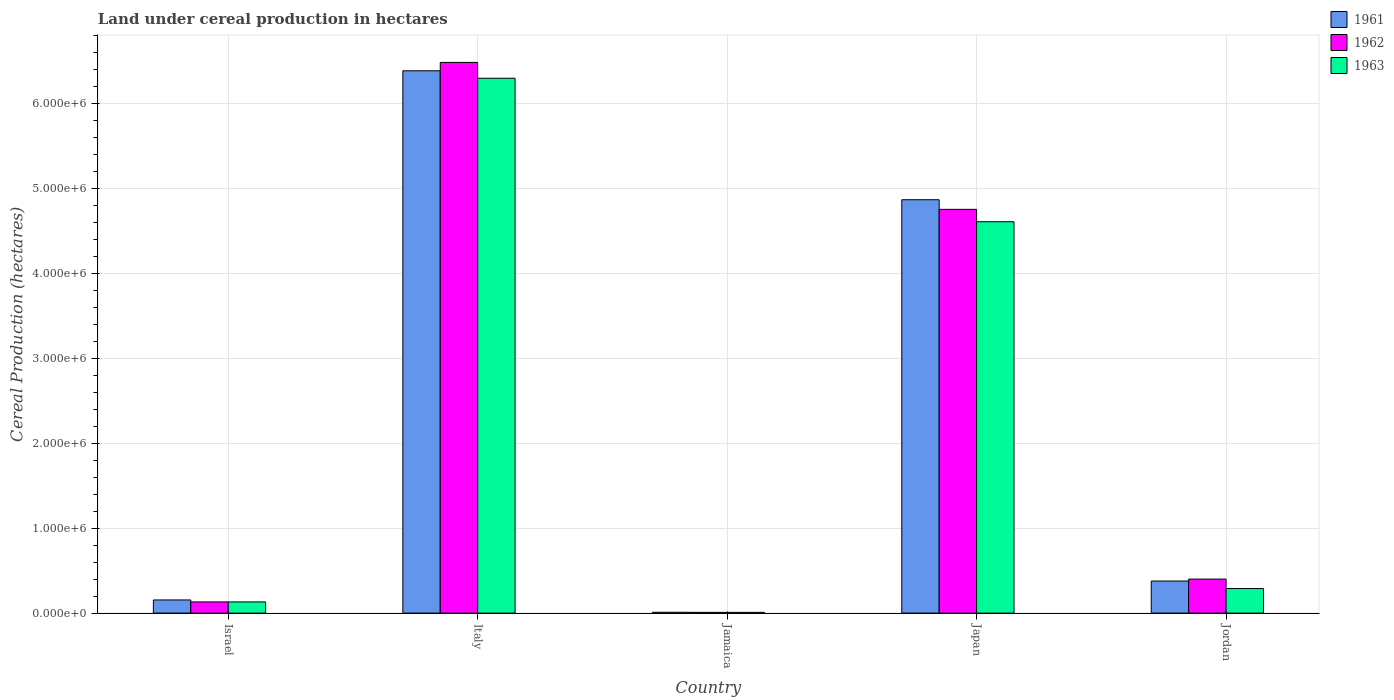How many groups of bars are there?
Your response must be concise. 5. Are the number of bars on each tick of the X-axis equal?
Offer a terse response. Yes. How many bars are there on the 4th tick from the right?
Your response must be concise. 3. What is the label of the 5th group of bars from the left?
Make the answer very short. Jordan. What is the land under cereal production in 1962 in Japan?
Make the answer very short. 4.76e+06. Across all countries, what is the maximum land under cereal production in 1961?
Make the answer very short. 6.39e+06. Across all countries, what is the minimum land under cereal production in 1962?
Your answer should be very brief. 8579. In which country was the land under cereal production in 1963 minimum?
Make the answer very short. Jamaica. What is the total land under cereal production in 1962 in the graph?
Make the answer very short. 1.18e+07. What is the difference between the land under cereal production in 1963 in Jamaica and that in Jordan?
Ensure brevity in your answer.  -2.80e+05. What is the difference between the land under cereal production in 1962 in Israel and the land under cereal production in 1961 in Jamaica?
Give a very brief answer. 1.22e+05. What is the average land under cereal production in 1961 per country?
Give a very brief answer. 2.36e+06. What is the difference between the land under cereal production of/in 1963 and land under cereal production of/in 1962 in Italy?
Offer a very short reply. -1.86e+05. What is the ratio of the land under cereal production in 1961 in Japan to that in Jordan?
Your answer should be very brief. 12.89. Is the land under cereal production in 1961 in Israel less than that in Italy?
Ensure brevity in your answer.  Yes. Is the difference between the land under cereal production in 1963 in Italy and Jordan greater than the difference between the land under cereal production in 1962 in Italy and Jordan?
Your response must be concise. No. What is the difference between the highest and the second highest land under cereal production in 1961?
Offer a very short reply. -1.52e+06. What is the difference between the highest and the lowest land under cereal production in 1963?
Your answer should be compact. 6.29e+06. What does the 1st bar from the left in Italy represents?
Keep it short and to the point. 1961. Is it the case that in every country, the sum of the land under cereal production in 1961 and land under cereal production in 1963 is greater than the land under cereal production in 1962?
Your answer should be very brief. Yes. What is the difference between two consecutive major ticks on the Y-axis?
Provide a short and direct response. 1.00e+06. Does the graph contain any zero values?
Keep it short and to the point. No. Does the graph contain grids?
Give a very brief answer. Yes. Where does the legend appear in the graph?
Make the answer very short. Top right. How many legend labels are there?
Your answer should be compact. 3. What is the title of the graph?
Give a very brief answer. Land under cereal production in hectares. Does "2011" appear as one of the legend labels in the graph?
Ensure brevity in your answer.  No. What is the label or title of the X-axis?
Your answer should be compact. Country. What is the label or title of the Y-axis?
Give a very brief answer. Cereal Production (hectares). What is the Cereal Production (hectares) in 1961 in Israel?
Your response must be concise. 1.55e+05. What is the Cereal Production (hectares) in 1962 in Israel?
Offer a very short reply. 1.32e+05. What is the Cereal Production (hectares) in 1963 in Israel?
Provide a short and direct response. 1.32e+05. What is the Cereal Production (hectares) in 1961 in Italy?
Give a very brief answer. 6.39e+06. What is the Cereal Production (hectares) in 1962 in Italy?
Keep it short and to the point. 6.49e+06. What is the Cereal Production (hectares) of 1963 in Italy?
Offer a terse response. 6.30e+06. What is the Cereal Production (hectares) of 1961 in Jamaica?
Make the answer very short. 9712. What is the Cereal Production (hectares) of 1962 in Jamaica?
Your answer should be very brief. 8579. What is the Cereal Production (hectares) in 1963 in Jamaica?
Your response must be concise. 8619. What is the Cereal Production (hectares) in 1961 in Japan?
Offer a terse response. 4.87e+06. What is the Cereal Production (hectares) of 1962 in Japan?
Give a very brief answer. 4.76e+06. What is the Cereal Production (hectares) of 1963 in Japan?
Give a very brief answer. 4.61e+06. What is the Cereal Production (hectares) of 1961 in Jordan?
Provide a short and direct response. 3.78e+05. What is the Cereal Production (hectares) of 1962 in Jordan?
Offer a terse response. 4.01e+05. What is the Cereal Production (hectares) of 1963 in Jordan?
Your answer should be compact. 2.89e+05. Across all countries, what is the maximum Cereal Production (hectares) of 1961?
Your response must be concise. 6.39e+06. Across all countries, what is the maximum Cereal Production (hectares) in 1962?
Provide a succinct answer. 6.49e+06. Across all countries, what is the maximum Cereal Production (hectares) of 1963?
Offer a terse response. 6.30e+06. Across all countries, what is the minimum Cereal Production (hectares) in 1961?
Your response must be concise. 9712. Across all countries, what is the minimum Cereal Production (hectares) in 1962?
Your answer should be compact. 8579. Across all countries, what is the minimum Cereal Production (hectares) of 1963?
Give a very brief answer. 8619. What is the total Cereal Production (hectares) of 1961 in the graph?
Make the answer very short. 1.18e+07. What is the total Cereal Production (hectares) of 1962 in the graph?
Offer a very short reply. 1.18e+07. What is the total Cereal Production (hectares) in 1963 in the graph?
Your answer should be very brief. 1.13e+07. What is the difference between the Cereal Production (hectares) of 1961 in Israel and that in Italy?
Ensure brevity in your answer.  -6.23e+06. What is the difference between the Cereal Production (hectares) in 1962 in Israel and that in Italy?
Provide a short and direct response. -6.35e+06. What is the difference between the Cereal Production (hectares) of 1963 in Israel and that in Italy?
Give a very brief answer. -6.17e+06. What is the difference between the Cereal Production (hectares) of 1961 in Israel and that in Jamaica?
Your answer should be very brief. 1.45e+05. What is the difference between the Cereal Production (hectares) in 1962 in Israel and that in Jamaica?
Provide a short and direct response. 1.23e+05. What is the difference between the Cereal Production (hectares) of 1963 in Israel and that in Jamaica?
Offer a very short reply. 1.23e+05. What is the difference between the Cereal Production (hectares) of 1961 in Israel and that in Japan?
Keep it short and to the point. -4.71e+06. What is the difference between the Cereal Production (hectares) of 1962 in Israel and that in Japan?
Ensure brevity in your answer.  -4.62e+06. What is the difference between the Cereal Production (hectares) in 1963 in Israel and that in Japan?
Provide a succinct answer. -4.48e+06. What is the difference between the Cereal Production (hectares) of 1961 in Israel and that in Jordan?
Ensure brevity in your answer.  -2.23e+05. What is the difference between the Cereal Production (hectares) in 1962 in Israel and that in Jordan?
Your answer should be very brief. -2.69e+05. What is the difference between the Cereal Production (hectares) in 1963 in Israel and that in Jordan?
Provide a succinct answer. -1.57e+05. What is the difference between the Cereal Production (hectares) of 1961 in Italy and that in Jamaica?
Offer a very short reply. 6.38e+06. What is the difference between the Cereal Production (hectares) of 1962 in Italy and that in Jamaica?
Your response must be concise. 6.48e+06. What is the difference between the Cereal Production (hectares) in 1963 in Italy and that in Jamaica?
Provide a short and direct response. 6.29e+06. What is the difference between the Cereal Production (hectares) in 1961 in Italy and that in Japan?
Your answer should be compact. 1.52e+06. What is the difference between the Cereal Production (hectares) in 1962 in Italy and that in Japan?
Your answer should be very brief. 1.73e+06. What is the difference between the Cereal Production (hectares) of 1963 in Italy and that in Japan?
Provide a short and direct response. 1.69e+06. What is the difference between the Cereal Production (hectares) of 1961 in Italy and that in Jordan?
Keep it short and to the point. 6.01e+06. What is the difference between the Cereal Production (hectares) of 1962 in Italy and that in Jordan?
Your answer should be compact. 6.09e+06. What is the difference between the Cereal Production (hectares) in 1963 in Italy and that in Jordan?
Give a very brief answer. 6.01e+06. What is the difference between the Cereal Production (hectares) in 1961 in Jamaica and that in Japan?
Provide a short and direct response. -4.86e+06. What is the difference between the Cereal Production (hectares) of 1962 in Jamaica and that in Japan?
Give a very brief answer. -4.75e+06. What is the difference between the Cereal Production (hectares) in 1963 in Jamaica and that in Japan?
Your answer should be compact. -4.60e+06. What is the difference between the Cereal Production (hectares) in 1961 in Jamaica and that in Jordan?
Offer a very short reply. -3.68e+05. What is the difference between the Cereal Production (hectares) of 1962 in Jamaica and that in Jordan?
Your response must be concise. -3.92e+05. What is the difference between the Cereal Production (hectares) in 1963 in Jamaica and that in Jordan?
Offer a very short reply. -2.80e+05. What is the difference between the Cereal Production (hectares) in 1961 in Japan and that in Jordan?
Make the answer very short. 4.49e+06. What is the difference between the Cereal Production (hectares) in 1962 in Japan and that in Jordan?
Offer a terse response. 4.35e+06. What is the difference between the Cereal Production (hectares) in 1963 in Japan and that in Jordan?
Your response must be concise. 4.32e+06. What is the difference between the Cereal Production (hectares) in 1961 in Israel and the Cereal Production (hectares) in 1962 in Italy?
Your response must be concise. -6.33e+06. What is the difference between the Cereal Production (hectares) in 1961 in Israel and the Cereal Production (hectares) in 1963 in Italy?
Your answer should be very brief. -6.14e+06. What is the difference between the Cereal Production (hectares) in 1962 in Israel and the Cereal Production (hectares) in 1963 in Italy?
Offer a very short reply. -6.17e+06. What is the difference between the Cereal Production (hectares) of 1961 in Israel and the Cereal Production (hectares) of 1962 in Jamaica?
Make the answer very short. 1.46e+05. What is the difference between the Cereal Production (hectares) in 1961 in Israel and the Cereal Production (hectares) in 1963 in Jamaica?
Give a very brief answer. 1.46e+05. What is the difference between the Cereal Production (hectares) in 1962 in Israel and the Cereal Production (hectares) in 1963 in Jamaica?
Offer a terse response. 1.23e+05. What is the difference between the Cereal Production (hectares) of 1961 in Israel and the Cereal Production (hectares) of 1962 in Japan?
Your response must be concise. -4.60e+06. What is the difference between the Cereal Production (hectares) in 1961 in Israel and the Cereal Production (hectares) in 1963 in Japan?
Your response must be concise. -4.45e+06. What is the difference between the Cereal Production (hectares) in 1962 in Israel and the Cereal Production (hectares) in 1963 in Japan?
Your answer should be compact. -4.48e+06. What is the difference between the Cereal Production (hectares) of 1961 in Israel and the Cereal Production (hectares) of 1962 in Jordan?
Provide a succinct answer. -2.46e+05. What is the difference between the Cereal Production (hectares) of 1961 in Israel and the Cereal Production (hectares) of 1963 in Jordan?
Provide a succinct answer. -1.34e+05. What is the difference between the Cereal Production (hectares) of 1962 in Israel and the Cereal Production (hectares) of 1963 in Jordan?
Ensure brevity in your answer.  -1.57e+05. What is the difference between the Cereal Production (hectares) in 1961 in Italy and the Cereal Production (hectares) in 1962 in Jamaica?
Make the answer very short. 6.38e+06. What is the difference between the Cereal Production (hectares) in 1961 in Italy and the Cereal Production (hectares) in 1963 in Jamaica?
Ensure brevity in your answer.  6.38e+06. What is the difference between the Cereal Production (hectares) in 1962 in Italy and the Cereal Production (hectares) in 1963 in Jamaica?
Your response must be concise. 6.48e+06. What is the difference between the Cereal Production (hectares) in 1961 in Italy and the Cereal Production (hectares) in 1962 in Japan?
Offer a terse response. 1.63e+06. What is the difference between the Cereal Production (hectares) of 1961 in Italy and the Cereal Production (hectares) of 1963 in Japan?
Offer a very short reply. 1.78e+06. What is the difference between the Cereal Production (hectares) of 1962 in Italy and the Cereal Production (hectares) of 1963 in Japan?
Your answer should be very brief. 1.88e+06. What is the difference between the Cereal Production (hectares) of 1961 in Italy and the Cereal Production (hectares) of 1962 in Jordan?
Your answer should be compact. 5.99e+06. What is the difference between the Cereal Production (hectares) in 1961 in Italy and the Cereal Production (hectares) in 1963 in Jordan?
Provide a succinct answer. 6.10e+06. What is the difference between the Cereal Production (hectares) of 1962 in Italy and the Cereal Production (hectares) of 1963 in Jordan?
Keep it short and to the point. 6.20e+06. What is the difference between the Cereal Production (hectares) in 1961 in Jamaica and the Cereal Production (hectares) in 1962 in Japan?
Provide a succinct answer. -4.75e+06. What is the difference between the Cereal Production (hectares) in 1961 in Jamaica and the Cereal Production (hectares) in 1963 in Japan?
Your answer should be very brief. -4.60e+06. What is the difference between the Cereal Production (hectares) in 1962 in Jamaica and the Cereal Production (hectares) in 1963 in Japan?
Give a very brief answer. -4.60e+06. What is the difference between the Cereal Production (hectares) in 1961 in Jamaica and the Cereal Production (hectares) in 1962 in Jordan?
Offer a very short reply. -3.91e+05. What is the difference between the Cereal Production (hectares) in 1961 in Jamaica and the Cereal Production (hectares) in 1963 in Jordan?
Your answer should be very brief. -2.79e+05. What is the difference between the Cereal Production (hectares) of 1962 in Jamaica and the Cereal Production (hectares) of 1963 in Jordan?
Make the answer very short. -2.80e+05. What is the difference between the Cereal Production (hectares) in 1961 in Japan and the Cereal Production (hectares) in 1962 in Jordan?
Provide a short and direct response. 4.47e+06. What is the difference between the Cereal Production (hectares) in 1961 in Japan and the Cereal Production (hectares) in 1963 in Jordan?
Ensure brevity in your answer.  4.58e+06. What is the difference between the Cereal Production (hectares) of 1962 in Japan and the Cereal Production (hectares) of 1963 in Jordan?
Keep it short and to the point. 4.47e+06. What is the average Cereal Production (hectares) of 1961 per country?
Keep it short and to the point. 2.36e+06. What is the average Cereal Production (hectares) in 1962 per country?
Keep it short and to the point. 2.36e+06. What is the average Cereal Production (hectares) in 1963 per country?
Offer a terse response. 2.27e+06. What is the difference between the Cereal Production (hectares) in 1961 and Cereal Production (hectares) in 1962 in Israel?
Provide a succinct answer. 2.32e+04. What is the difference between the Cereal Production (hectares) of 1961 and Cereal Production (hectares) of 1963 in Israel?
Your answer should be compact. 2.31e+04. What is the difference between the Cereal Production (hectares) of 1962 and Cereal Production (hectares) of 1963 in Israel?
Offer a very short reply. -132. What is the difference between the Cereal Production (hectares) of 1961 and Cereal Production (hectares) of 1962 in Italy?
Make the answer very short. -9.87e+04. What is the difference between the Cereal Production (hectares) of 1961 and Cereal Production (hectares) of 1963 in Italy?
Make the answer very short. 8.77e+04. What is the difference between the Cereal Production (hectares) of 1962 and Cereal Production (hectares) of 1963 in Italy?
Offer a terse response. 1.86e+05. What is the difference between the Cereal Production (hectares) of 1961 and Cereal Production (hectares) of 1962 in Jamaica?
Provide a short and direct response. 1133. What is the difference between the Cereal Production (hectares) of 1961 and Cereal Production (hectares) of 1963 in Jamaica?
Offer a very short reply. 1093. What is the difference between the Cereal Production (hectares) of 1961 and Cereal Production (hectares) of 1962 in Japan?
Make the answer very short. 1.13e+05. What is the difference between the Cereal Production (hectares) of 1961 and Cereal Production (hectares) of 1963 in Japan?
Your answer should be compact. 2.59e+05. What is the difference between the Cereal Production (hectares) of 1962 and Cereal Production (hectares) of 1963 in Japan?
Offer a very short reply. 1.46e+05. What is the difference between the Cereal Production (hectares) in 1961 and Cereal Production (hectares) in 1962 in Jordan?
Keep it short and to the point. -2.28e+04. What is the difference between the Cereal Production (hectares) of 1961 and Cereal Production (hectares) of 1963 in Jordan?
Ensure brevity in your answer.  8.87e+04. What is the difference between the Cereal Production (hectares) in 1962 and Cereal Production (hectares) in 1963 in Jordan?
Offer a terse response. 1.12e+05. What is the ratio of the Cereal Production (hectares) of 1961 in Israel to that in Italy?
Offer a terse response. 0.02. What is the ratio of the Cereal Production (hectares) in 1962 in Israel to that in Italy?
Give a very brief answer. 0.02. What is the ratio of the Cereal Production (hectares) in 1963 in Israel to that in Italy?
Provide a short and direct response. 0.02. What is the ratio of the Cereal Production (hectares) in 1961 in Israel to that in Jamaica?
Offer a very short reply. 15.95. What is the ratio of the Cereal Production (hectares) in 1962 in Israel to that in Jamaica?
Your response must be concise. 15.34. What is the ratio of the Cereal Production (hectares) of 1963 in Israel to that in Jamaica?
Offer a terse response. 15.29. What is the ratio of the Cereal Production (hectares) in 1961 in Israel to that in Japan?
Your answer should be very brief. 0.03. What is the ratio of the Cereal Production (hectares) of 1962 in Israel to that in Japan?
Keep it short and to the point. 0.03. What is the ratio of the Cereal Production (hectares) of 1963 in Israel to that in Japan?
Your answer should be compact. 0.03. What is the ratio of the Cereal Production (hectares) of 1961 in Israel to that in Jordan?
Your response must be concise. 0.41. What is the ratio of the Cereal Production (hectares) of 1962 in Israel to that in Jordan?
Provide a short and direct response. 0.33. What is the ratio of the Cereal Production (hectares) of 1963 in Israel to that in Jordan?
Give a very brief answer. 0.46. What is the ratio of the Cereal Production (hectares) in 1961 in Italy to that in Jamaica?
Give a very brief answer. 657.66. What is the ratio of the Cereal Production (hectares) of 1962 in Italy to that in Jamaica?
Provide a short and direct response. 756.02. What is the ratio of the Cereal Production (hectares) in 1963 in Italy to that in Jamaica?
Your answer should be compact. 730.88. What is the ratio of the Cereal Production (hectares) in 1961 in Italy to that in Japan?
Your answer should be compact. 1.31. What is the ratio of the Cereal Production (hectares) in 1962 in Italy to that in Japan?
Provide a succinct answer. 1.36. What is the ratio of the Cereal Production (hectares) in 1963 in Italy to that in Japan?
Make the answer very short. 1.37. What is the ratio of the Cereal Production (hectares) in 1961 in Italy to that in Jordan?
Offer a terse response. 16.91. What is the ratio of the Cereal Production (hectares) of 1962 in Italy to that in Jordan?
Give a very brief answer. 16.19. What is the ratio of the Cereal Production (hectares) in 1963 in Italy to that in Jordan?
Provide a succinct answer. 21.79. What is the ratio of the Cereal Production (hectares) in 1961 in Jamaica to that in Japan?
Your answer should be compact. 0. What is the ratio of the Cereal Production (hectares) of 1962 in Jamaica to that in Japan?
Give a very brief answer. 0. What is the ratio of the Cereal Production (hectares) in 1963 in Jamaica to that in Japan?
Your answer should be compact. 0. What is the ratio of the Cereal Production (hectares) of 1961 in Jamaica to that in Jordan?
Make the answer very short. 0.03. What is the ratio of the Cereal Production (hectares) of 1962 in Jamaica to that in Jordan?
Give a very brief answer. 0.02. What is the ratio of the Cereal Production (hectares) in 1963 in Jamaica to that in Jordan?
Provide a succinct answer. 0.03. What is the ratio of the Cereal Production (hectares) in 1961 in Japan to that in Jordan?
Give a very brief answer. 12.89. What is the ratio of the Cereal Production (hectares) of 1962 in Japan to that in Jordan?
Make the answer very short. 11.87. What is the ratio of the Cereal Production (hectares) in 1963 in Japan to that in Jordan?
Ensure brevity in your answer.  15.95. What is the difference between the highest and the second highest Cereal Production (hectares) in 1961?
Your answer should be compact. 1.52e+06. What is the difference between the highest and the second highest Cereal Production (hectares) of 1962?
Make the answer very short. 1.73e+06. What is the difference between the highest and the second highest Cereal Production (hectares) in 1963?
Make the answer very short. 1.69e+06. What is the difference between the highest and the lowest Cereal Production (hectares) of 1961?
Your answer should be very brief. 6.38e+06. What is the difference between the highest and the lowest Cereal Production (hectares) of 1962?
Your answer should be compact. 6.48e+06. What is the difference between the highest and the lowest Cereal Production (hectares) in 1963?
Provide a succinct answer. 6.29e+06. 